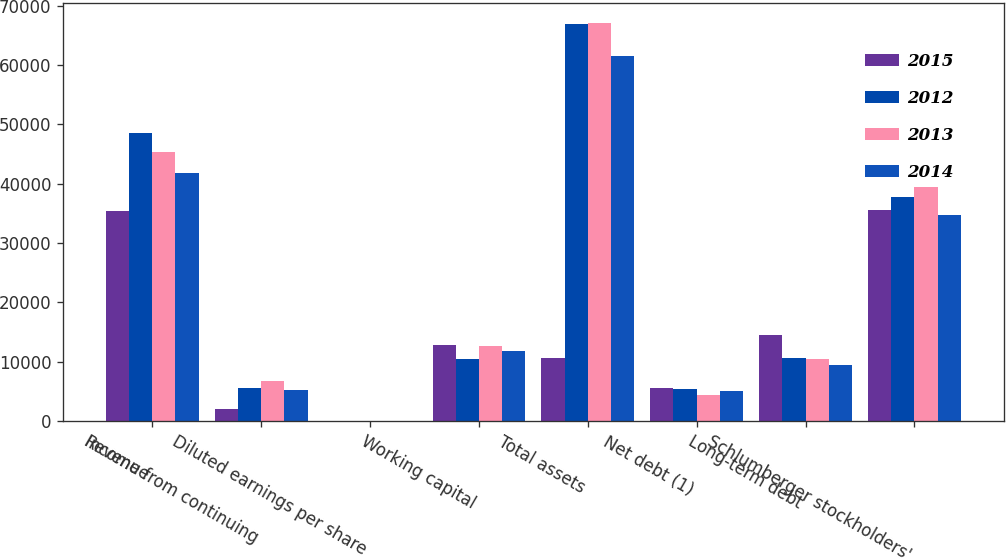Convert chart to OTSL. <chart><loc_0><loc_0><loc_500><loc_500><stacked_bar_chart><ecel><fcel>Revenue<fcel>Income from continuing<fcel>Diluted earnings per share<fcel>Working capital<fcel>Total assets<fcel>Net debt (1)<fcel>Long-term debt<fcel>Schlumberger stockholders'<nl><fcel>2015<fcel>35475<fcel>2072<fcel>1.63<fcel>12791<fcel>10565<fcel>5547<fcel>14442<fcel>35633<nl><fcel>2012<fcel>48580<fcel>5643<fcel>4.31<fcel>10518<fcel>66904<fcel>5387<fcel>10565<fcel>37850<nl><fcel>2013<fcel>45266<fcel>6801<fcel>5.1<fcel>12700<fcel>67100<fcel>4443<fcel>10393<fcel>39469<nl><fcel>2014<fcel>41731<fcel>5230<fcel>3.91<fcel>11788<fcel>61547<fcel>5111<fcel>9509<fcel>34751<nl></chart> 